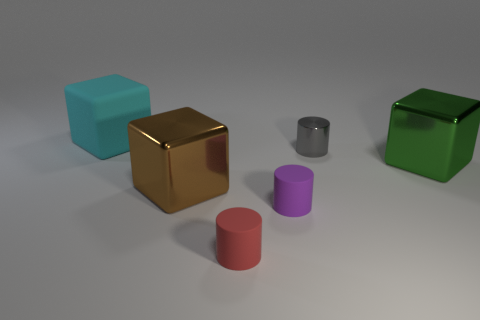Subtract all small red matte cylinders. How many cylinders are left? 2 Add 1 large brown metal things. How many objects exist? 7 Subtract all brown blocks. How many blocks are left? 2 Subtract 2 cylinders. How many cylinders are left? 1 Subtract all purple spheres. How many purple cylinders are left? 1 Subtract all tiny gray cylinders. Subtract all small purple matte things. How many objects are left? 4 Add 2 rubber cubes. How many rubber cubes are left? 3 Add 1 tiny green balls. How many tiny green balls exist? 1 Subtract 0 brown cylinders. How many objects are left? 6 Subtract all blue cubes. Subtract all gray cylinders. How many cubes are left? 3 